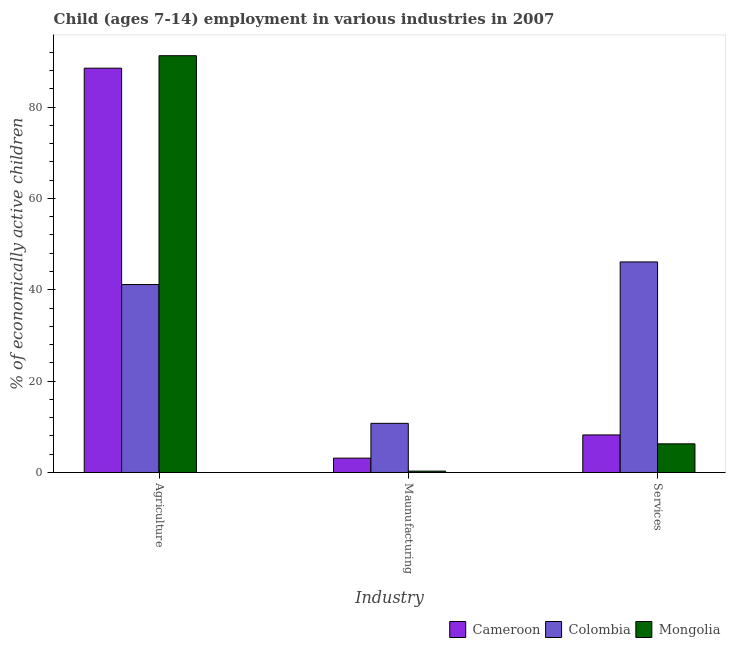How many groups of bars are there?
Make the answer very short. 3. Are the number of bars per tick equal to the number of legend labels?
Your response must be concise. Yes. Are the number of bars on each tick of the X-axis equal?
Give a very brief answer. Yes. What is the label of the 1st group of bars from the left?
Provide a short and direct response. Agriculture. What is the percentage of economically active children in agriculture in Cameroon?
Your answer should be compact. 88.52. Across all countries, what is the maximum percentage of economically active children in services?
Ensure brevity in your answer.  46.1. In which country was the percentage of economically active children in services maximum?
Make the answer very short. Colombia. In which country was the percentage of economically active children in services minimum?
Your answer should be compact. Mongolia. What is the total percentage of economically active children in services in the graph?
Offer a very short reply. 60.59. What is the difference between the percentage of economically active children in agriculture in Cameroon and that in Mongolia?
Offer a very short reply. -2.73. What is the difference between the percentage of economically active children in services in Colombia and the percentage of economically active children in manufacturing in Mongolia?
Ensure brevity in your answer.  45.8. What is the average percentage of economically active children in services per country?
Ensure brevity in your answer.  20.2. What is the difference between the percentage of economically active children in manufacturing and percentage of economically active children in agriculture in Mongolia?
Give a very brief answer. -90.95. In how many countries, is the percentage of economically active children in services greater than 8 %?
Keep it short and to the point. 2. What is the ratio of the percentage of economically active children in manufacturing in Mongolia to that in Cameroon?
Provide a succinct answer. 0.1. What is the difference between the highest and the second highest percentage of economically active children in services?
Your answer should be compact. 37.88. What is the difference between the highest and the lowest percentage of economically active children in services?
Make the answer very short. 39.83. In how many countries, is the percentage of economically active children in manufacturing greater than the average percentage of economically active children in manufacturing taken over all countries?
Your response must be concise. 1. What does the 1st bar from the left in Agriculture represents?
Give a very brief answer. Cameroon. What does the 3rd bar from the right in Maunufacturing represents?
Keep it short and to the point. Cameroon. Is it the case that in every country, the sum of the percentage of economically active children in agriculture and percentage of economically active children in manufacturing is greater than the percentage of economically active children in services?
Ensure brevity in your answer.  Yes. How many bars are there?
Keep it short and to the point. 9. What is the title of the graph?
Your response must be concise. Child (ages 7-14) employment in various industries in 2007. Does "Central African Republic" appear as one of the legend labels in the graph?
Offer a very short reply. No. What is the label or title of the X-axis?
Your response must be concise. Industry. What is the label or title of the Y-axis?
Keep it short and to the point. % of economically active children. What is the % of economically active children in Cameroon in Agriculture?
Your answer should be very brief. 88.52. What is the % of economically active children of Colombia in Agriculture?
Your answer should be very brief. 41.15. What is the % of economically active children of Mongolia in Agriculture?
Give a very brief answer. 91.25. What is the % of economically active children in Cameroon in Maunufacturing?
Your answer should be very brief. 3.14. What is the % of economically active children in Colombia in Maunufacturing?
Offer a terse response. 10.76. What is the % of economically active children in Mongolia in Maunufacturing?
Offer a very short reply. 0.3. What is the % of economically active children in Cameroon in Services?
Your answer should be compact. 8.22. What is the % of economically active children of Colombia in Services?
Your answer should be compact. 46.1. What is the % of economically active children in Mongolia in Services?
Make the answer very short. 6.27. Across all Industry, what is the maximum % of economically active children in Cameroon?
Provide a short and direct response. 88.52. Across all Industry, what is the maximum % of economically active children of Colombia?
Offer a very short reply. 46.1. Across all Industry, what is the maximum % of economically active children of Mongolia?
Ensure brevity in your answer.  91.25. Across all Industry, what is the minimum % of economically active children of Cameroon?
Provide a short and direct response. 3.14. Across all Industry, what is the minimum % of economically active children in Colombia?
Your response must be concise. 10.76. Across all Industry, what is the minimum % of economically active children of Mongolia?
Ensure brevity in your answer.  0.3. What is the total % of economically active children in Cameroon in the graph?
Keep it short and to the point. 99.88. What is the total % of economically active children of Colombia in the graph?
Keep it short and to the point. 98.01. What is the total % of economically active children of Mongolia in the graph?
Ensure brevity in your answer.  97.82. What is the difference between the % of economically active children of Cameroon in Agriculture and that in Maunufacturing?
Ensure brevity in your answer.  85.38. What is the difference between the % of economically active children in Colombia in Agriculture and that in Maunufacturing?
Keep it short and to the point. 30.39. What is the difference between the % of economically active children in Mongolia in Agriculture and that in Maunufacturing?
Provide a short and direct response. 90.95. What is the difference between the % of economically active children of Cameroon in Agriculture and that in Services?
Your response must be concise. 80.3. What is the difference between the % of economically active children in Colombia in Agriculture and that in Services?
Ensure brevity in your answer.  -4.95. What is the difference between the % of economically active children in Mongolia in Agriculture and that in Services?
Your answer should be very brief. 84.98. What is the difference between the % of economically active children of Cameroon in Maunufacturing and that in Services?
Provide a succinct answer. -5.08. What is the difference between the % of economically active children of Colombia in Maunufacturing and that in Services?
Your answer should be very brief. -35.34. What is the difference between the % of economically active children in Mongolia in Maunufacturing and that in Services?
Keep it short and to the point. -5.97. What is the difference between the % of economically active children of Cameroon in Agriculture and the % of economically active children of Colombia in Maunufacturing?
Give a very brief answer. 77.76. What is the difference between the % of economically active children in Cameroon in Agriculture and the % of economically active children in Mongolia in Maunufacturing?
Provide a short and direct response. 88.22. What is the difference between the % of economically active children of Colombia in Agriculture and the % of economically active children of Mongolia in Maunufacturing?
Give a very brief answer. 40.85. What is the difference between the % of economically active children of Cameroon in Agriculture and the % of economically active children of Colombia in Services?
Ensure brevity in your answer.  42.42. What is the difference between the % of economically active children of Cameroon in Agriculture and the % of economically active children of Mongolia in Services?
Ensure brevity in your answer.  82.25. What is the difference between the % of economically active children in Colombia in Agriculture and the % of economically active children in Mongolia in Services?
Ensure brevity in your answer.  34.88. What is the difference between the % of economically active children of Cameroon in Maunufacturing and the % of economically active children of Colombia in Services?
Provide a succinct answer. -42.96. What is the difference between the % of economically active children in Cameroon in Maunufacturing and the % of economically active children in Mongolia in Services?
Offer a very short reply. -3.13. What is the difference between the % of economically active children of Colombia in Maunufacturing and the % of economically active children of Mongolia in Services?
Provide a short and direct response. 4.49. What is the average % of economically active children in Cameroon per Industry?
Make the answer very short. 33.29. What is the average % of economically active children of Colombia per Industry?
Ensure brevity in your answer.  32.67. What is the average % of economically active children of Mongolia per Industry?
Keep it short and to the point. 32.61. What is the difference between the % of economically active children in Cameroon and % of economically active children in Colombia in Agriculture?
Your answer should be compact. 47.37. What is the difference between the % of economically active children in Cameroon and % of economically active children in Mongolia in Agriculture?
Give a very brief answer. -2.73. What is the difference between the % of economically active children of Colombia and % of economically active children of Mongolia in Agriculture?
Provide a short and direct response. -50.1. What is the difference between the % of economically active children in Cameroon and % of economically active children in Colombia in Maunufacturing?
Provide a short and direct response. -7.62. What is the difference between the % of economically active children in Cameroon and % of economically active children in Mongolia in Maunufacturing?
Make the answer very short. 2.84. What is the difference between the % of economically active children of Colombia and % of economically active children of Mongolia in Maunufacturing?
Ensure brevity in your answer.  10.46. What is the difference between the % of economically active children in Cameroon and % of economically active children in Colombia in Services?
Offer a terse response. -37.88. What is the difference between the % of economically active children of Cameroon and % of economically active children of Mongolia in Services?
Your answer should be compact. 1.95. What is the difference between the % of economically active children of Colombia and % of economically active children of Mongolia in Services?
Offer a very short reply. 39.83. What is the ratio of the % of economically active children in Cameroon in Agriculture to that in Maunufacturing?
Your response must be concise. 28.19. What is the ratio of the % of economically active children of Colombia in Agriculture to that in Maunufacturing?
Keep it short and to the point. 3.82. What is the ratio of the % of economically active children in Mongolia in Agriculture to that in Maunufacturing?
Give a very brief answer. 304.17. What is the ratio of the % of economically active children in Cameroon in Agriculture to that in Services?
Offer a terse response. 10.77. What is the ratio of the % of economically active children of Colombia in Agriculture to that in Services?
Make the answer very short. 0.89. What is the ratio of the % of economically active children of Mongolia in Agriculture to that in Services?
Give a very brief answer. 14.55. What is the ratio of the % of economically active children in Cameroon in Maunufacturing to that in Services?
Ensure brevity in your answer.  0.38. What is the ratio of the % of economically active children of Colombia in Maunufacturing to that in Services?
Give a very brief answer. 0.23. What is the ratio of the % of economically active children in Mongolia in Maunufacturing to that in Services?
Your answer should be compact. 0.05. What is the difference between the highest and the second highest % of economically active children in Cameroon?
Ensure brevity in your answer.  80.3. What is the difference between the highest and the second highest % of economically active children in Colombia?
Make the answer very short. 4.95. What is the difference between the highest and the second highest % of economically active children in Mongolia?
Your answer should be compact. 84.98. What is the difference between the highest and the lowest % of economically active children of Cameroon?
Your answer should be very brief. 85.38. What is the difference between the highest and the lowest % of economically active children in Colombia?
Make the answer very short. 35.34. What is the difference between the highest and the lowest % of economically active children in Mongolia?
Offer a very short reply. 90.95. 